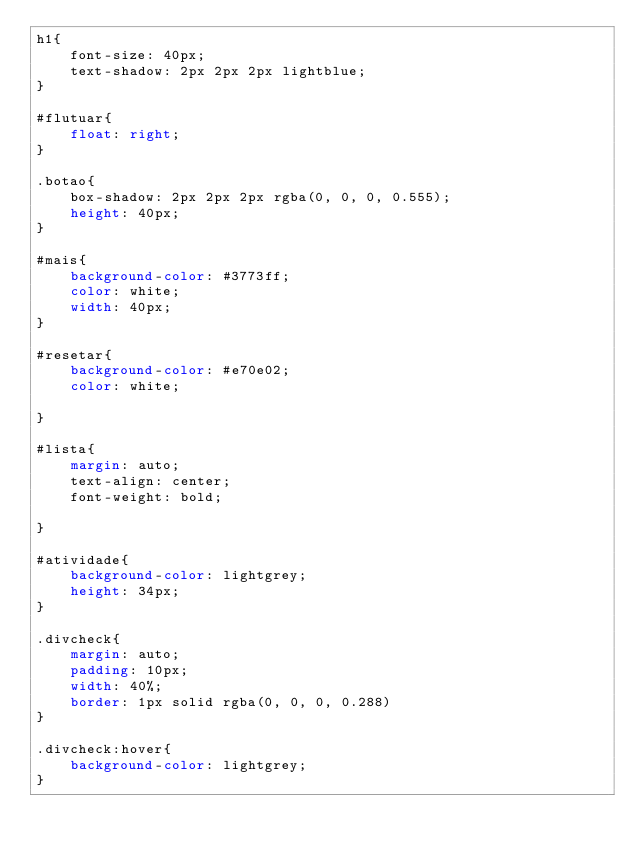<code> <loc_0><loc_0><loc_500><loc_500><_CSS_>h1{
    font-size: 40px;
    text-shadow: 2px 2px 2px lightblue;
}

#flutuar{
    float: right;
}

.botao{
    box-shadow: 2px 2px 2px rgba(0, 0, 0, 0.555);
    height: 40px;
}

#mais{
    background-color: #3773ff;
    color: white;
    width: 40px;
}

#resetar{
    background-color: #e70e02;
    color: white;

}

#lista{
    margin: auto;
    text-align: center;
    font-weight: bold;
    
}

#atividade{
    background-color: lightgrey;
    height: 34px;
}

.divcheck{    
    margin: auto;
    padding: 10px;
    width: 40%;
    border: 1px solid rgba(0, 0, 0, 0.288)
}

.divcheck:hover{
    background-color: lightgrey;
}</code> 